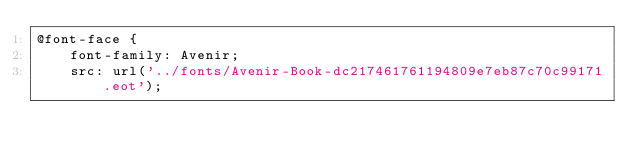<code> <loc_0><loc_0><loc_500><loc_500><_CSS_>@font-face {
    font-family: Avenir;
    src: url('../fonts/Avenir-Book-dc217461761194809e7eb87c70c99171.eot');</code> 